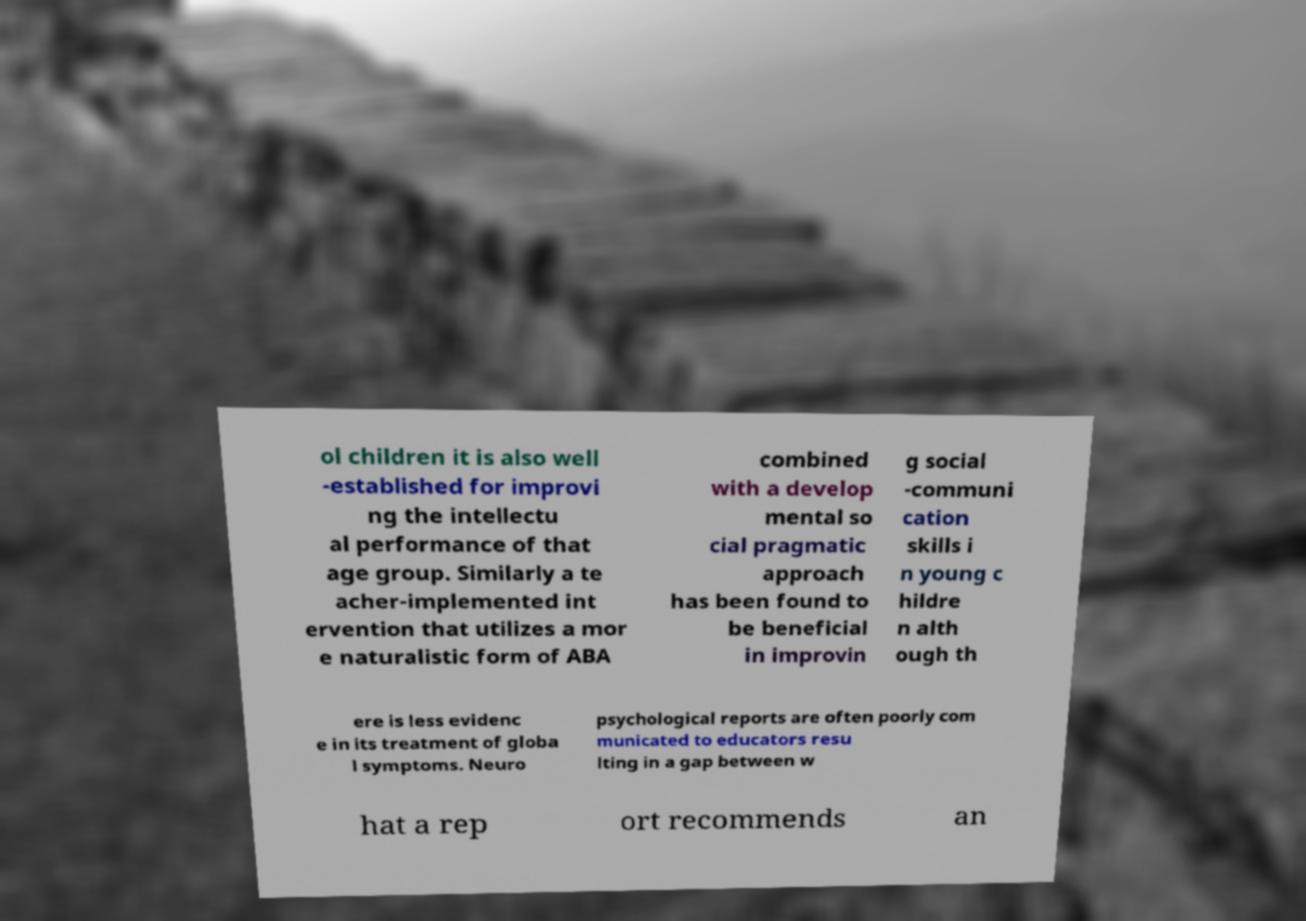Could you assist in decoding the text presented in this image and type it out clearly? ol children it is also well -established for improvi ng the intellectu al performance of that age group. Similarly a te acher-implemented int ervention that utilizes a mor e naturalistic form of ABA combined with a develop mental so cial pragmatic approach has been found to be beneficial in improvin g social -communi cation skills i n young c hildre n alth ough th ere is less evidenc e in its treatment of globa l symptoms. Neuro psychological reports are often poorly com municated to educators resu lting in a gap between w hat a rep ort recommends an 